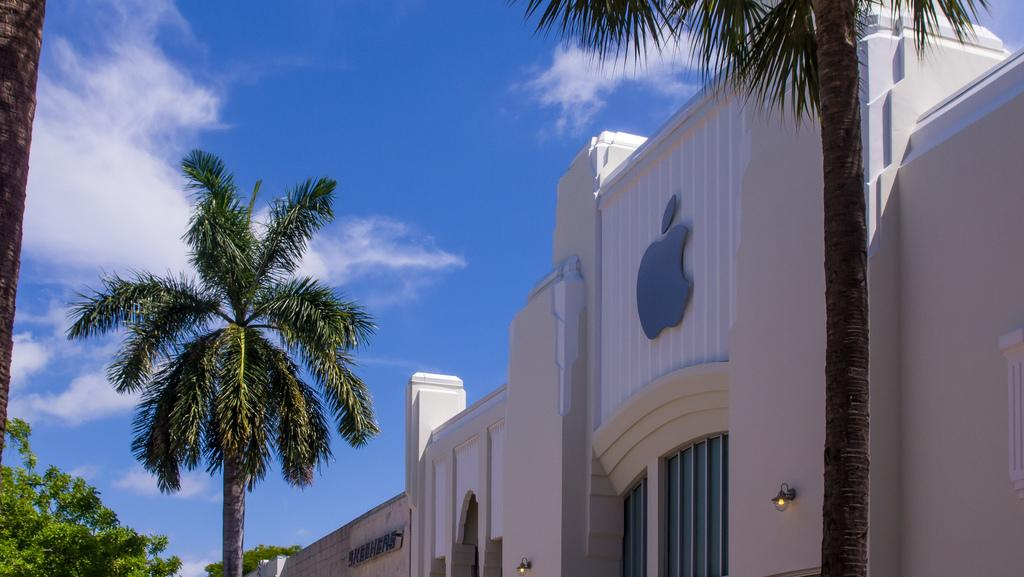What type of vegetation can be seen in the image? There are trees in the image. What type of structure is present in the image? There is a building in the image. What color is the sky in the background of the image? The sky is blue in the background of the image. Can you see any quicksand in the image? There is no quicksand present in the image. What type of ring is being worn by the tree in the image? There are no rings, whether worn or not, present in the image, as trees do not wear rings. 